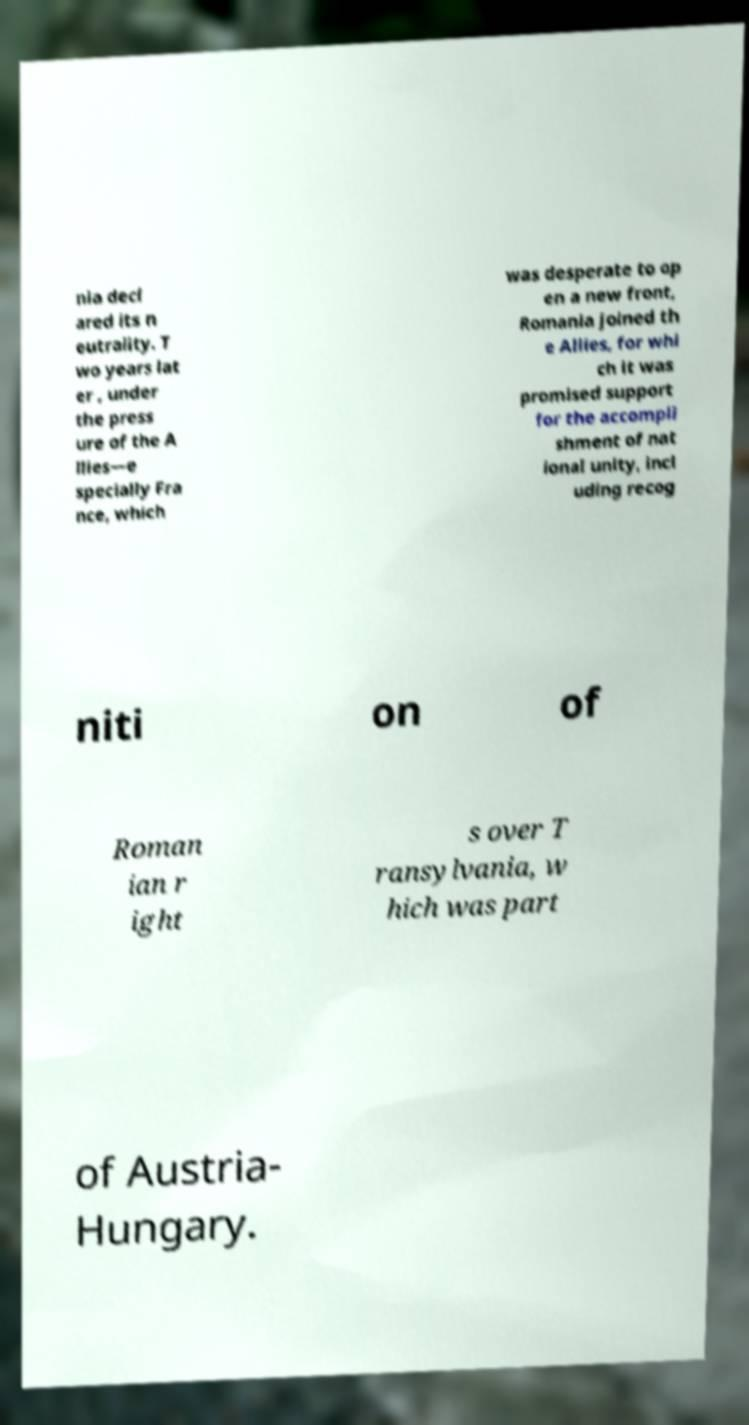Could you extract and type out the text from this image? nia decl ared its n eutrality. T wo years lat er , under the press ure of the A llies—e specially Fra nce, which was desperate to op en a new front, Romania joined th e Allies, for whi ch it was promised support for the accompli shment of nat ional unity, incl uding recog niti on of Roman ian r ight s over T ransylvania, w hich was part of Austria- Hungary. 